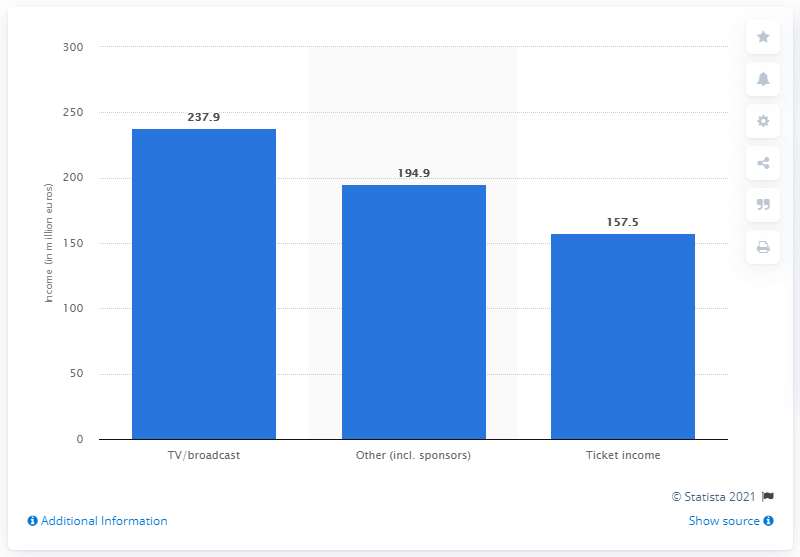Outline some significant characteristics in this image. The total income generated from ticketing sales at all 24 clubs in the 2011/12 season was 157.5 million pounds. 